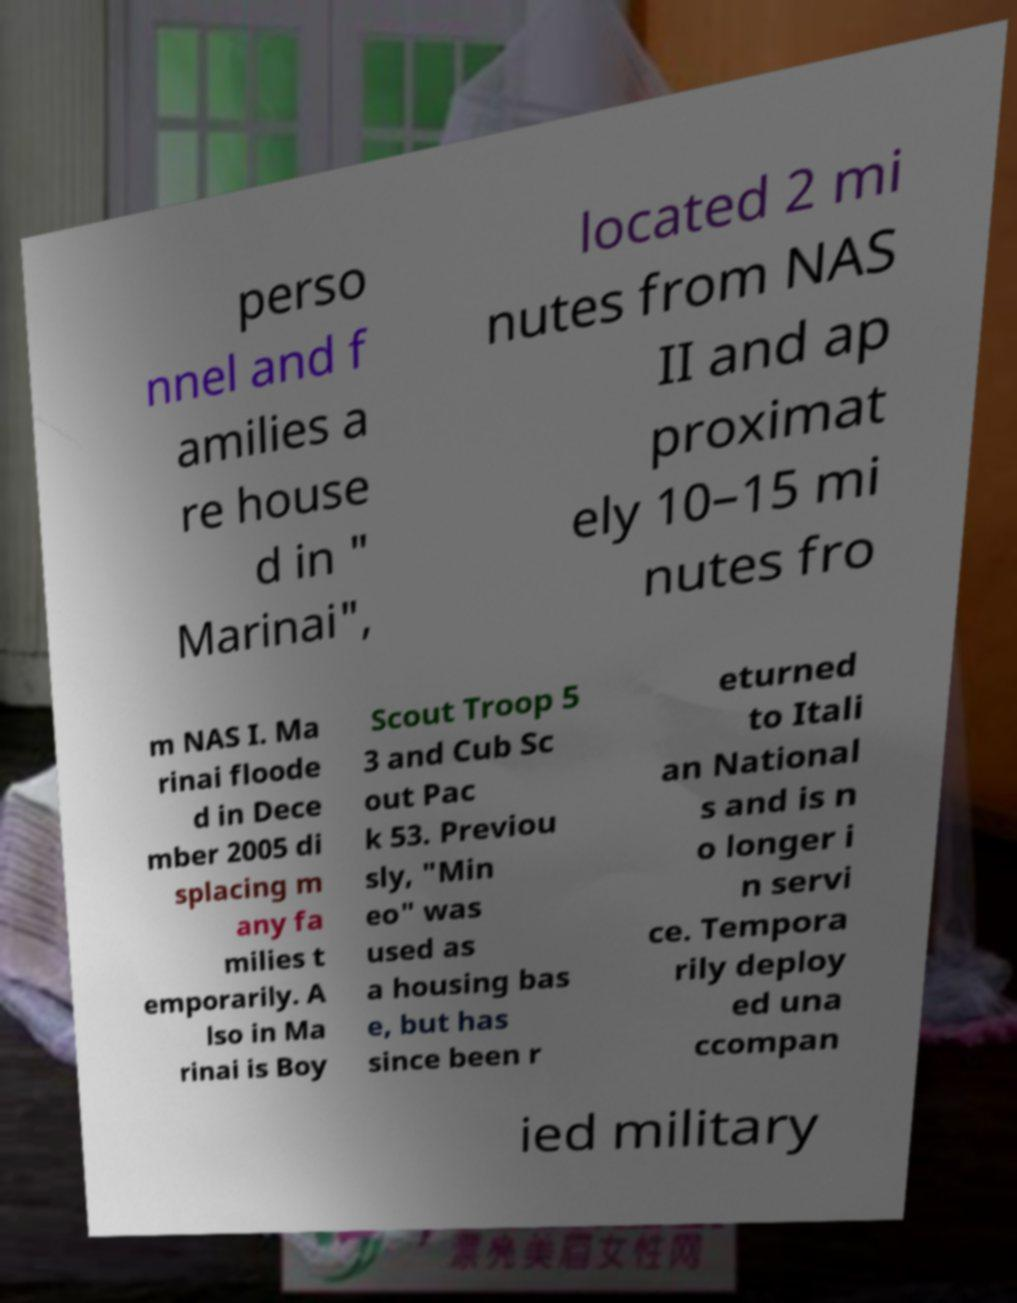There's text embedded in this image that I need extracted. Can you transcribe it verbatim? perso nnel and f amilies a re house d in " Marinai", located 2 mi nutes from NAS II and ap proximat ely 10–15 mi nutes fro m NAS I. Ma rinai floode d in Dece mber 2005 di splacing m any fa milies t emporarily. A lso in Ma rinai is Boy Scout Troop 5 3 and Cub Sc out Pac k 53. Previou sly, "Min eo" was used as a housing bas e, but has since been r eturned to Itali an National s and is n o longer i n servi ce. Tempora rily deploy ed una ccompan ied military 